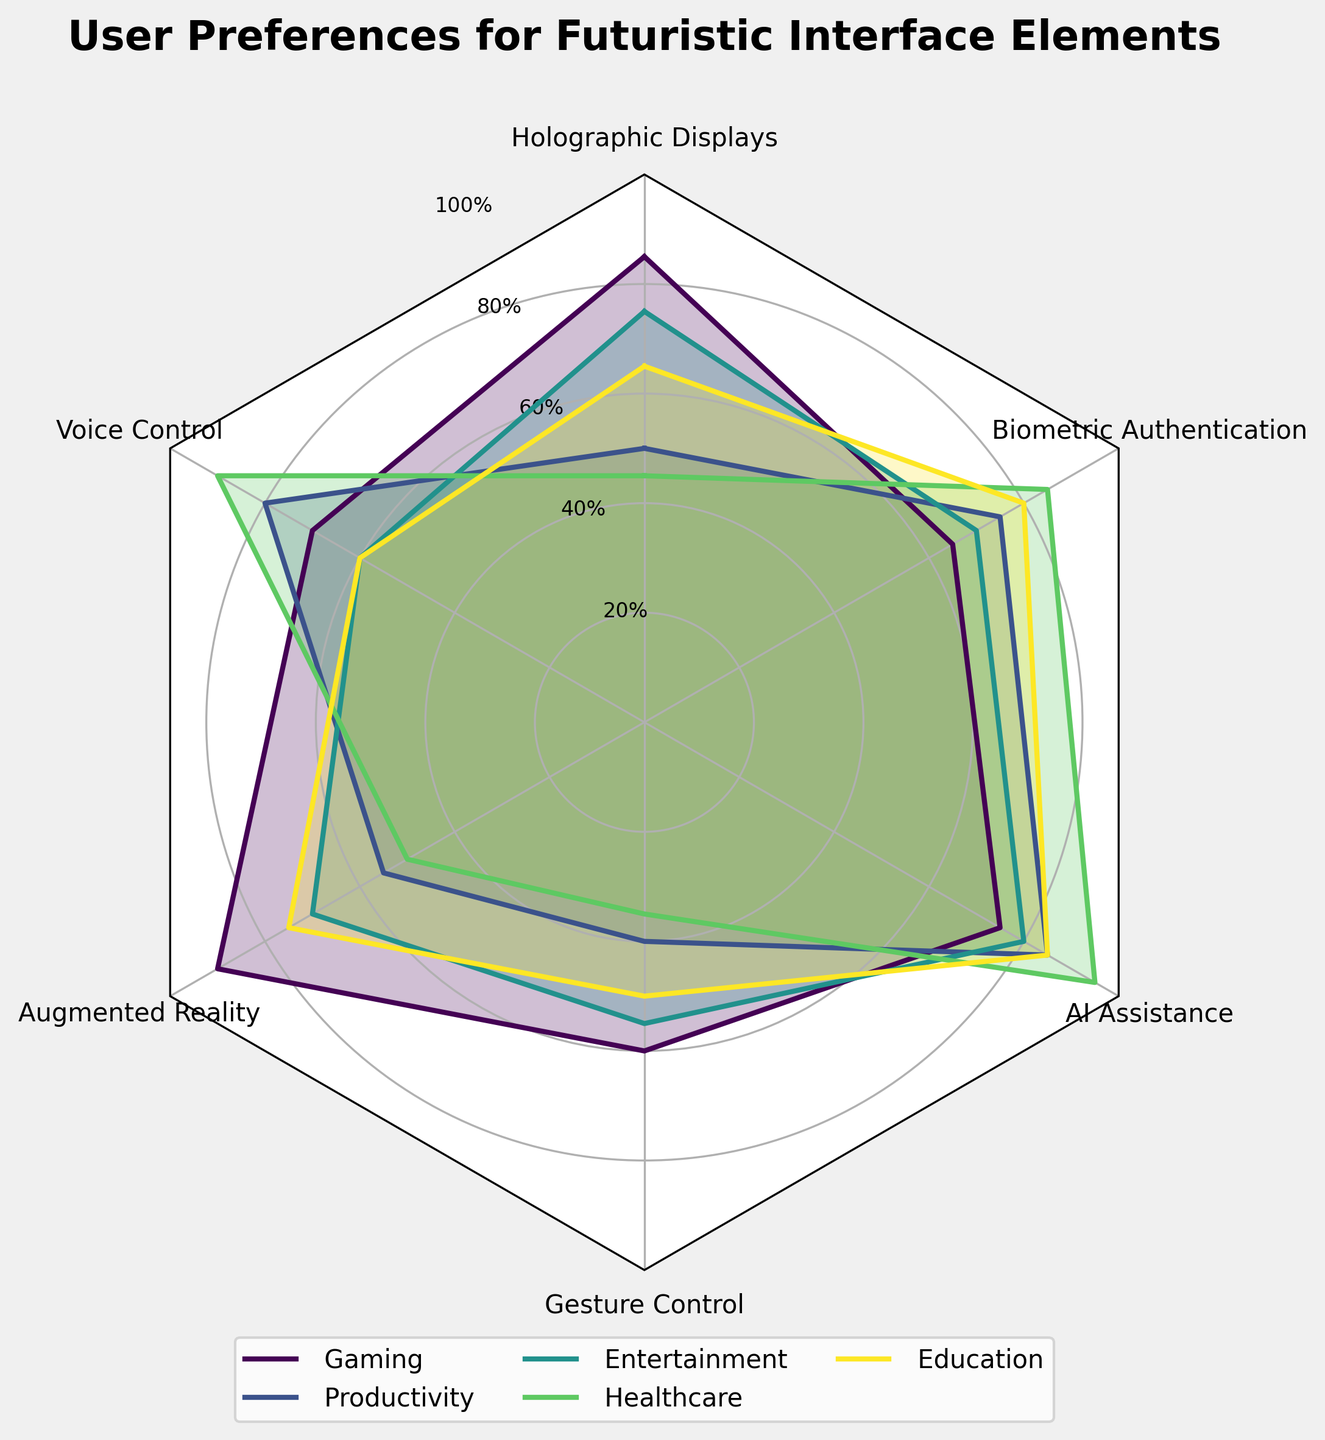what is the title of the radar chart? The title is located at the top center of the chart and it reads: "User Preferences for Futuristic Interface Elements."
Answer: User Preferences for Futuristic Interface Elements How many slices are there in the radar chart? Each slice represents a category of user preferences. Counting these reveals there are six slices.
Answer: Six Which futuristic interface element is preferred the most in gaming? By looking at the "Gaming" data points, the highest value appears on the "Augmented Reality" section.
Answer: Augmented Reality Between Voice Control and Gesture Control, which one is less preferred in the Healthcare context? Comparing the data points for "Voice Control" and "Gesture Control" in Healthcare, "Gesture Control" shows a lower preference value.
Answer: Gesture Control What is the average user preference score for Holographic Displays across all contexts? Summing the values for Holographic Displays (85, 50, 75, 45, 65) and dividing by the number of contexts (5) gives: (85 + 50 + 75 + 45 + 65) / 5 = 64.
Answer: 64 Which context shows the highest preference for AI Assistance? By checking all the values under AI Assistance, the highest score (95) is found in the Healthcare context.
Answer: Healthcare Are Biometric Authentication preferences higher in Education compared to Entertainment? Comparing the values in the Biometric Authentication row, Education (80) has a higher value than Entertainment (70).
Answer: Yes Which futuristic interface element has the least variation in user preference across all contexts? Evaluating the range of each futuristic interface element, it appears "Voice Control" has relatively uniform scores ranging from 60 to 90.
Answer: Voice Control What's the sum of preference values for Augmented Reality in Gaming and Education contexts? Adding the preference values for Augmented Reality in Gaming (90) and Education (75) results in: 90 + 75 = 165.
Answer: 165 Which futuristic interface element performs the worst in Productivity context? By comparing all the values under the 'Productivity' context, "Gesture Control" has the lowest value of 40.
Answer: Gesture Control 